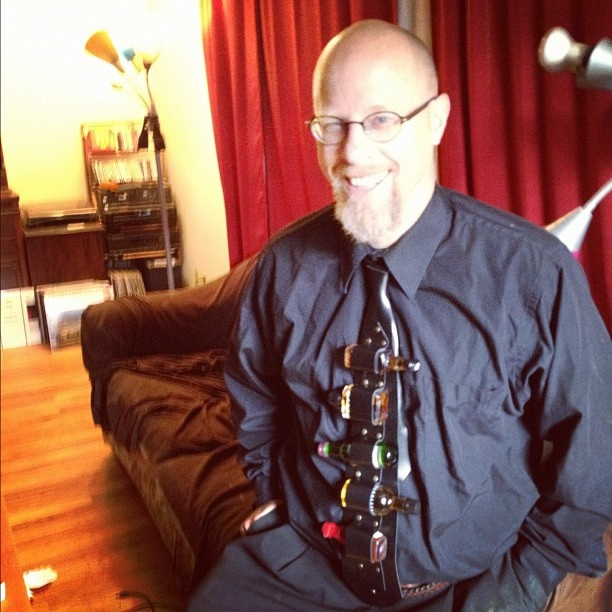Describe the objects in this image and their specific colors. I can see people in gray, black, and ivory tones, couch in gray, maroon, and brown tones, tie in gray, black, maroon, and darkgray tones, bottle in gray, black, maroon, and darkgray tones, and bottle in gray, black, and white tones in this image. 